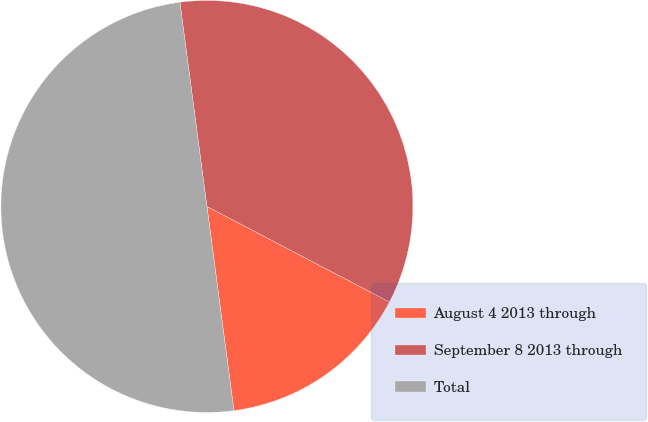<chart> <loc_0><loc_0><loc_500><loc_500><pie_chart><fcel>August 4 2013 through<fcel>September 8 2013 through<fcel>Total<nl><fcel>15.23%<fcel>34.77%<fcel>50.0%<nl></chart> 